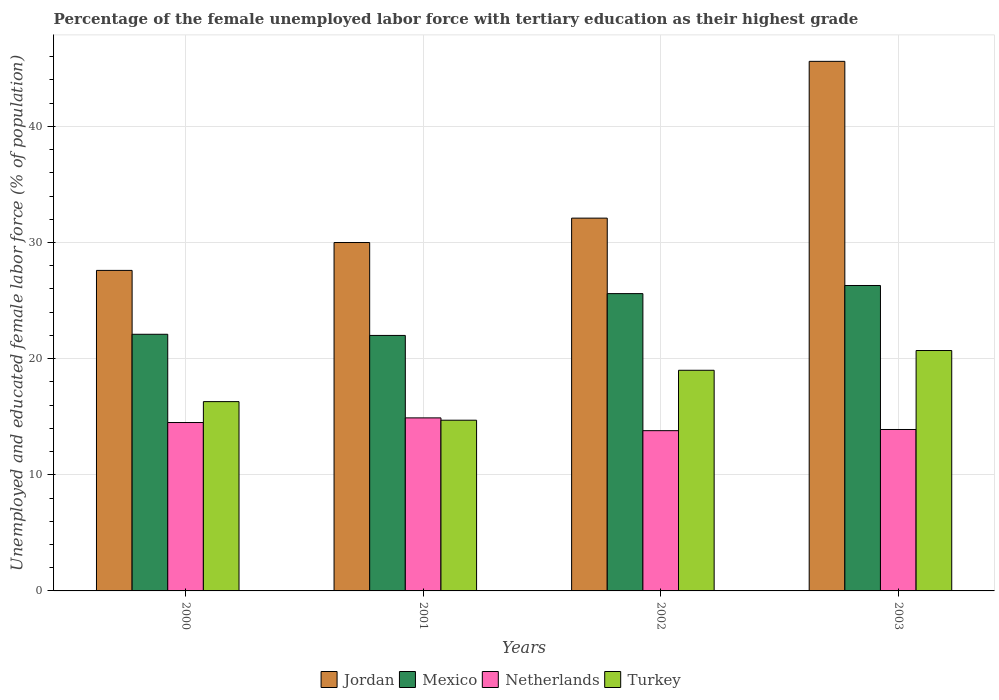Are the number of bars per tick equal to the number of legend labels?
Offer a very short reply. Yes. Are the number of bars on each tick of the X-axis equal?
Your answer should be very brief. Yes. How many bars are there on the 3rd tick from the right?
Give a very brief answer. 4. What is the label of the 2nd group of bars from the left?
Offer a very short reply. 2001. In how many cases, is the number of bars for a given year not equal to the number of legend labels?
Offer a terse response. 0. What is the percentage of the unemployed female labor force with tertiary education in Turkey in 2003?
Ensure brevity in your answer.  20.7. Across all years, what is the maximum percentage of the unemployed female labor force with tertiary education in Netherlands?
Give a very brief answer. 14.9. Across all years, what is the minimum percentage of the unemployed female labor force with tertiary education in Turkey?
Provide a short and direct response. 14.7. What is the total percentage of the unemployed female labor force with tertiary education in Netherlands in the graph?
Your answer should be compact. 57.1. What is the difference between the percentage of the unemployed female labor force with tertiary education in Jordan in 2000 and that in 2001?
Your response must be concise. -2.4. What is the difference between the percentage of the unemployed female labor force with tertiary education in Mexico in 2000 and the percentage of the unemployed female labor force with tertiary education in Turkey in 2002?
Offer a terse response. 3.1. What is the average percentage of the unemployed female labor force with tertiary education in Netherlands per year?
Make the answer very short. 14.27. In the year 2000, what is the difference between the percentage of the unemployed female labor force with tertiary education in Netherlands and percentage of the unemployed female labor force with tertiary education in Mexico?
Your answer should be compact. -7.6. In how many years, is the percentage of the unemployed female labor force with tertiary education in Turkey greater than 28 %?
Offer a terse response. 0. What is the ratio of the percentage of the unemployed female labor force with tertiary education in Jordan in 2000 to that in 2003?
Provide a short and direct response. 0.61. Is the difference between the percentage of the unemployed female labor force with tertiary education in Netherlands in 2001 and 2002 greater than the difference between the percentage of the unemployed female labor force with tertiary education in Mexico in 2001 and 2002?
Make the answer very short. Yes. What is the difference between the highest and the second highest percentage of the unemployed female labor force with tertiary education in Mexico?
Offer a very short reply. 0.7. What is the difference between the highest and the lowest percentage of the unemployed female labor force with tertiary education in Netherlands?
Keep it short and to the point. 1.1. In how many years, is the percentage of the unemployed female labor force with tertiary education in Netherlands greater than the average percentage of the unemployed female labor force with tertiary education in Netherlands taken over all years?
Provide a short and direct response. 2. Is it the case that in every year, the sum of the percentage of the unemployed female labor force with tertiary education in Netherlands and percentage of the unemployed female labor force with tertiary education in Jordan is greater than the sum of percentage of the unemployed female labor force with tertiary education in Turkey and percentage of the unemployed female labor force with tertiary education in Mexico?
Offer a terse response. No. What does the 1st bar from the left in 2000 represents?
Give a very brief answer. Jordan. How many bars are there?
Ensure brevity in your answer.  16. Does the graph contain grids?
Provide a succinct answer. Yes. How many legend labels are there?
Offer a terse response. 4. How are the legend labels stacked?
Ensure brevity in your answer.  Horizontal. What is the title of the graph?
Make the answer very short. Percentage of the female unemployed labor force with tertiary education as their highest grade. What is the label or title of the Y-axis?
Make the answer very short. Unemployed and educated female labor force (% of population). What is the Unemployed and educated female labor force (% of population) in Jordan in 2000?
Keep it short and to the point. 27.6. What is the Unemployed and educated female labor force (% of population) in Mexico in 2000?
Ensure brevity in your answer.  22.1. What is the Unemployed and educated female labor force (% of population) in Netherlands in 2000?
Offer a very short reply. 14.5. What is the Unemployed and educated female labor force (% of population) in Turkey in 2000?
Your answer should be compact. 16.3. What is the Unemployed and educated female labor force (% of population) in Mexico in 2001?
Offer a very short reply. 22. What is the Unemployed and educated female labor force (% of population) in Netherlands in 2001?
Keep it short and to the point. 14.9. What is the Unemployed and educated female labor force (% of population) of Turkey in 2001?
Offer a terse response. 14.7. What is the Unemployed and educated female labor force (% of population) in Jordan in 2002?
Your answer should be compact. 32.1. What is the Unemployed and educated female labor force (% of population) in Mexico in 2002?
Your answer should be compact. 25.6. What is the Unemployed and educated female labor force (% of population) of Netherlands in 2002?
Give a very brief answer. 13.8. What is the Unemployed and educated female labor force (% of population) of Turkey in 2002?
Give a very brief answer. 19. What is the Unemployed and educated female labor force (% of population) in Jordan in 2003?
Provide a succinct answer. 45.6. What is the Unemployed and educated female labor force (% of population) of Mexico in 2003?
Make the answer very short. 26.3. What is the Unemployed and educated female labor force (% of population) in Netherlands in 2003?
Ensure brevity in your answer.  13.9. What is the Unemployed and educated female labor force (% of population) of Turkey in 2003?
Your answer should be very brief. 20.7. Across all years, what is the maximum Unemployed and educated female labor force (% of population) in Jordan?
Your response must be concise. 45.6. Across all years, what is the maximum Unemployed and educated female labor force (% of population) in Mexico?
Make the answer very short. 26.3. Across all years, what is the maximum Unemployed and educated female labor force (% of population) of Netherlands?
Provide a succinct answer. 14.9. Across all years, what is the maximum Unemployed and educated female labor force (% of population) of Turkey?
Make the answer very short. 20.7. Across all years, what is the minimum Unemployed and educated female labor force (% of population) in Jordan?
Make the answer very short. 27.6. Across all years, what is the minimum Unemployed and educated female labor force (% of population) in Mexico?
Offer a terse response. 22. Across all years, what is the minimum Unemployed and educated female labor force (% of population) in Netherlands?
Provide a succinct answer. 13.8. Across all years, what is the minimum Unemployed and educated female labor force (% of population) of Turkey?
Give a very brief answer. 14.7. What is the total Unemployed and educated female labor force (% of population) of Jordan in the graph?
Keep it short and to the point. 135.3. What is the total Unemployed and educated female labor force (% of population) of Mexico in the graph?
Make the answer very short. 96. What is the total Unemployed and educated female labor force (% of population) of Netherlands in the graph?
Your response must be concise. 57.1. What is the total Unemployed and educated female labor force (% of population) in Turkey in the graph?
Your answer should be very brief. 70.7. What is the difference between the Unemployed and educated female labor force (% of population) of Turkey in 2000 and that in 2001?
Ensure brevity in your answer.  1.6. What is the difference between the Unemployed and educated female labor force (% of population) in Netherlands in 2000 and that in 2002?
Your answer should be very brief. 0.7. What is the difference between the Unemployed and educated female labor force (% of population) of Turkey in 2000 and that in 2002?
Your response must be concise. -2.7. What is the difference between the Unemployed and educated female labor force (% of population) of Jordan in 2000 and that in 2003?
Provide a short and direct response. -18. What is the difference between the Unemployed and educated female labor force (% of population) of Mexico in 2000 and that in 2003?
Your answer should be very brief. -4.2. What is the difference between the Unemployed and educated female labor force (% of population) of Turkey in 2000 and that in 2003?
Keep it short and to the point. -4.4. What is the difference between the Unemployed and educated female labor force (% of population) of Jordan in 2001 and that in 2002?
Your answer should be compact. -2.1. What is the difference between the Unemployed and educated female labor force (% of population) of Jordan in 2001 and that in 2003?
Offer a terse response. -15.6. What is the difference between the Unemployed and educated female labor force (% of population) of Netherlands in 2001 and that in 2003?
Your response must be concise. 1. What is the difference between the Unemployed and educated female labor force (% of population) of Turkey in 2001 and that in 2003?
Ensure brevity in your answer.  -6. What is the difference between the Unemployed and educated female labor force (% of population) of Mexico in 2002 and that in 2003?
Offer a very short reply. -0.7. What is the difference between the Unemployed and educated female labor force (% of population) in Jordan in 2000 and the Unemployed and educated female labor force (% of population) in Mexico in 2001?
Ensure brevity in your answer.  5.6. What is the difference between the Unemployed and educated female labor force (% of population) in Jordan in 2000 and the Unemployed and educated female labor force (% of population) in Turkey in 2001?
Your answer should be compact. 12.9. What is the difference between the Unemployed and educated female labor force (% of population) of Mexico in 2000 and the Unemployed and educated female labor force (% of population) of Turkey in 2001?
Keep it short and to the point. 7.4. What is the difference between the Unemployed and educated female labor force (% of population) of Netherlands in 2000 and the Unemployed and educated female labor force (% of population) of Turkey in 2001?
Give a very brief answer. -0.2. What is the difference between the Unemployed and educated female labor force (% of population) of Jordan in 2000 and the Unemployed and educated female labor force (% of population) of Turkey in 2002?
Give a very brief answer. 8.6. What is the difference between the Unemployed and educated female labor force (% of population) of Mexico in 2000 and the Unemployed and educated female labor force (% of population) of Turkey in 2002?
Offer a terse response. 3.1. What is the difference between the Unemployed and educated female labor force (% of population) in Netherlands in 2000 and the Unemployed and educated female labor force (% of population) in Turkey in 2002?
Your answer should be compact. -4.5. What is the difference between the Unemployed and educated female labor force (% of population) of Jordan in 2000 and the Unemployed and educated female labor force (% of population) of Netherlands in 2003?
Ensure brevity in your answer.  13.7. What is the difference between the Unemployed and educated female labor force (% of population) of Mexico in 2000 and the Unemployed and educated female labor force (% of population) of Netherlands in 2003?
Offer a terse response. 8.2. What is the difference between the Unemployed and educated female labor force (% of population) of Mexico in 2000 and the Unemployed and educated female labor force (% of population) of Turkey in 2003?
Keep it short and to the point. 1.4. What is the difference between the Unemployed and educated female labor force (% of population) in Jordan in 2001 and the Unemployed and educated female labor force (% of population) in Mexico in 2002?
Offer a terse response. 4.4. What is the difference between the Unemployed and educated female labor force (% of population) in Jordan in 2001 and the Unemployed and educated female labor force (% of population) in Netherlands in 2002?
Make the answer very short. 16.2. What is the difference between the Unemployed and educated female labor force (% of population) in Mexico in 2001 and the Unemployed and educated female labor force (% of population) in Netherlands in 2002?
Provide a succinct answer. 8.2. What is the difference between the Unemployed and educated female labor force (% of population) of Jordan in 2001 and the Unemployed and educated female labor force (% of population) of Mexico in 2003?
Provide a short and direct response. 3.7. What is the difference between the Unemployed and educated female labor force (% of population) of Mexico in 2001 and the Unemployed and educated female labor force (% of population) of Turkey in 2003?
Make the answer very short. 1.3. What is the difference between the Unemployed and educated female labor force (% of population) in Netherlands in 2001 and the Unemployed and educated female labor force (% of population) in Turkey in 2003?
Make the answer very short. -5.8. What is the difference between the Unemployed and educated female labor force (% of population) of Jordan in 2002 and the Unemployed and educated female labor force (% of population) of Mexico in 2003?
Provide a succinct answer. 5.8. What is the difference between the Unemployed and educated female labor force (% of population) of Jordan in 2002 and the Unemployed and educated female labor force (% of population) of Netherlands in 2003?
Offer a very short reply. 18.2. What is the difference between the Unemployed and educated female labor force (% of population) in Jordan in 2002 and the Unemployed and educated female labor force (% of population) in Turkey in 2003?
Provide a short and direct response. 11.4. What is the difference between the Unemployed and educated female labor force (% of population) in Mexico in 2002 and the Unemployed and educated female labor force (% of population) in Turkey in 2003?
Make the answer very short. 4.9. What is the average Unemployed and educated female labor force (% of population) in Jordan per year?
Your response must be concise. 33.83. What is the average Unemployed and educated female labor force (% of population) of Netherlands per year?
Provide a short and direct response. 14.28. What is the average Unemployed and educated female labor force (% of population) of Turkey per year?
Keep it short and to the point. 17.68. In the year 2000, what is the difference between the Unemployed and educated female labor force (% of population) of Jordan and Unemployed and educated female labor force (% of population) of Mexico?
Provide a short and direct response. 5.5. In the year 2000, what is the difference between the Unemployed and educated female labor force (% of population) in Jordan and Unemployed and educated female labor force (% of population) in Netherlands?
Provide a succinct answer. 13.1. In the year 2000, what is the difference between the Unemployed and educated female labor force (% of population) in Jordan and Unemployed and educated female labor force (% of population) in Turkey?
Your response must be concise. 11.3. In the year 2000, what is the difference between the Unemployed and educated female labor force (% of population) in Mexico and Unemployed and educated female labor force (% of population) in Turkey?
Provide a short and direct response. 5.8. In the year 2001, what is the difference between the Unemployed and educated female labor force (% of population) in Mexico and Unemployed and educated female labor force (% of population) in Netherlands?
Your response must be concise. 7.1. In the year 2001, what is the difference between the Unemployed and educated female labor force (% of population) in Mexico and Unemployed and educated female labor force (% of population) in Turkey?
Your answer should be very brief. 7.3. In the year 2001, what is the difference between the Unemployed and educated female labor force (% of population) in Netherlands and Unemployed and educated female labor force (% of population) in Turkey?
Your answer should be compact. 0.2. In the year 2002, what is the difference between the Unemployed and educated female labor force (% of population) in Jordan and Unemployed and educated female labor force (% of population) in Mexico?
Make the answer very short. 6.5. In the year 2002, what is the difference between the Unemployed and educated female labor force (% of population) of Jordan and Unemployed and educated female labor force (% of population) of Turkey?
Keep it short and to the point. 13.1. In the year 2002, what is the difference between the Unemployed and educated female labor force (% of population) of Mexico and Unemployed and educated female labor force (% of population) of Turkey?
Your response must be concise. 6.6. In the year 2003, what is the difference between the Unemployed and educated female labor force (% of population) of Jordan and Unemployed and educated female labor force (% of population) of Mexico?
Offer a very short reply. 19.3. In the year 2003, what is the difference between the Unemployed and educated female labor force (% of population) of Jordan and Unemployed and educated female labor force (% of population) of Netherlands?
Make the answer very short. 31.7. In the year 2003, what is the difference between the Unemployed and educated female labor force (% of population) of Jordan and Unemployed and educated female labor force (% of population) of Turkey?
Your answer should be very brief. 24.9. In the year 2003, what is the difference between the Unemployed and educated female labor force (% of population) in Mexico and Unemployed and educated female labor force (% of population) in Turkey?
Give a very brief answer. 5.6. In the year 2003, what is the difference between the Unemployed and educated female labor force (% of population) in Netherlands and Unemployed and educated female labor force (% of population) in Turkey?
Your answer should be compact. -6.8. What is the ratio of the Unemployed and educated female labor force (% of population) in Netherlands in 2000 to that in 2001?
Offer a very short reply. 0.97. What is the ratio of the Unemployed and educated female labor force (% of population) of Turkey in 2000 to that in 2001?
Your answer should be very brief. 1.11. What is the ratio of the Unemployed and educated female labor force (% of population) of Jordan in 2000 to that in 2002?
Offer a very short reply. 0.86. What is the ratio of the Unemployed and educated female labor force (% of population) of Mexico in 2000 to that in 2002?
Give a very brief answer. 0.86. What is the ratio of the Unemployed and educated female labor force (% of population) in Netherlands in 2000 to that in 2002?
Your answer should be very brief. 1.05. What is the ratio of the Unemployed and educated female labor force (% of population) in Turkey in 2000 to that in 2002?
Offer a terse response. 0.86. What is the ratio of the Unemployed and educated female labor force (% of population) in Jordan in 2000 to that in 2003?
Offer a terse response. 0.61. What is the ratio of the Unemployed and educated female labor force (% of population) in Mexico in 2000 to that in 2003?
Provide a short and direct response. 0.84. What is the ratio of the Unemployed and educated female labor force (% of population) of Netherlands in 2000 to that in 2003?
Give a very brief answer. 1.04. What is the ratio of the Unemployed and educated female labor force (% of population) in Turkey in 2000 to that in 2003?
Offer a terse response. 0.79. What is the ratio of the Unemployed and educated female labor force (% of population) in Jordan in 2001 to that in 2002?
Your answer should be very brief. 0.93. What is the ratio of the Unemployed and educated female labor force (% of population) of Mexico in 2001 to that in 2002?
Offer a very short reply. 0.86. What is the ratio of the Unemployed and educated female labor force (% of population) of Netherlands in 2001 to that in 2002?
Give a very brief answer. 1.08. What is the ratio of the Unemployed and educated female labor force (% of population) of Turkey in 2001 to that in 2002?
Offer a very short reply. 0.77. What is the ratio of the Unemployed and educated female labor force (% of population) in Jordan in 2001 to that in 2003?
Your response must be concise. 0.66. What is the ratio of the Unemployed and educated female labor force (% of population) in Mexico in 2001 to that in 2003?
Provide a succinct answer. 0.84. What is the ratio of the Unemployed and educated female labor force (% of population) in Netherlands in 2001 to that in 2003?
Your answer should be compact. 1.07. What is the ratio of the Unemployed and educated female labor force (% of population) of Turkey in 2001 to that in 2003?
Offer a terse response. 0.71. What is the ratio of the Unemployed and educated female labor force (% of population) in Jordan in 2002 to that in 2003?
Your answer should be very brief. 0.7. What is the ratio of the Unemployed and educated female labor force (% of population) in Mexico in 2002 to that in 2003?
Keep it short and to the point. 0.97. What is the ratio of the Unemployed and educated female labor force (% of population) in Netherlands in 2002 to that in 2003?
Your answer should be very brief. 0.99. What is the ratio of the Unemployed and educated female labor force (% of population) in Turkey in 2002 to that in 2003?
Ensure brevity in your answer.  0.92. What is the difference between the highest and the second highest Unemployed and educated female labor force (% of population) in Mexico?
Make the answer very short. 0.7. What is the difference between the highest and the second highest Unemployed and educated female labor force (% of population) of Netherlands?
Offer a very short reply. 0.4. What is the difference between the highest and the lowest Unemployed and educated female labor force (% of population) in Jordan?
Offer a very short reply. 18. What is the difference between the highest and the lowest Unemployed and educated female labor force (% of population) of Mexico?
Your response must be concise. 4.3. What is the difference between the highest and the lowest Unemployed and educated female labor force (% of population) of Netherlands?
Provide a succinct answer. 1.1. What is the difference between the highest and the lowest Unemployed and educated female labor force (% of population) in Turkey?
Give a very brief answer. 6. 